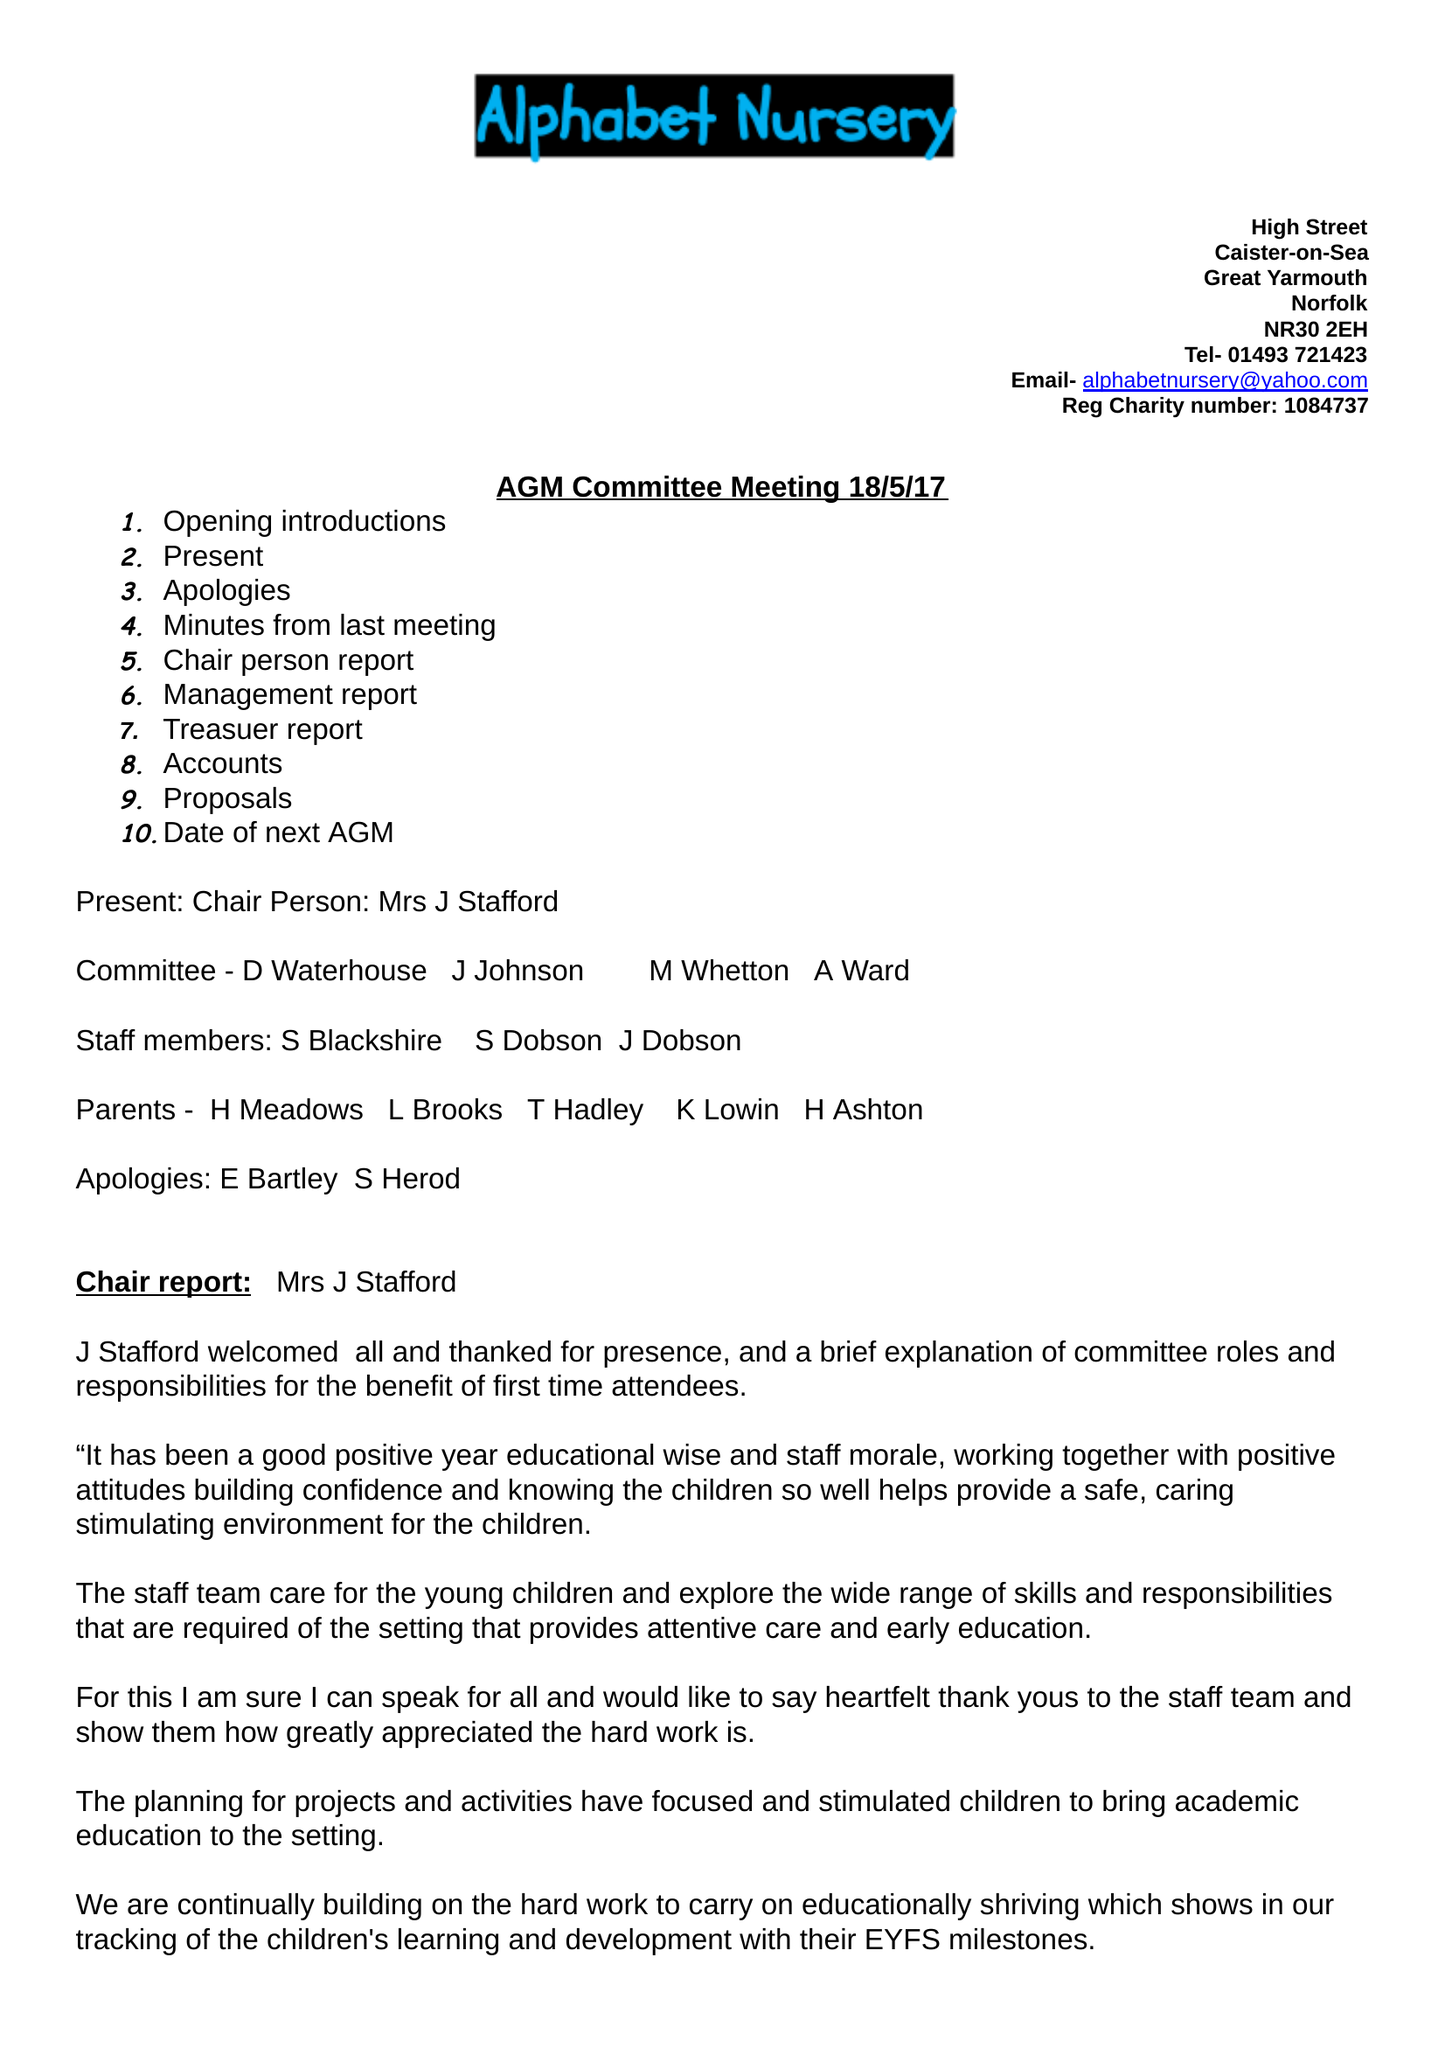What is the value for the report_date?
Answer the question using a single word or phrase. 2017-08-31 